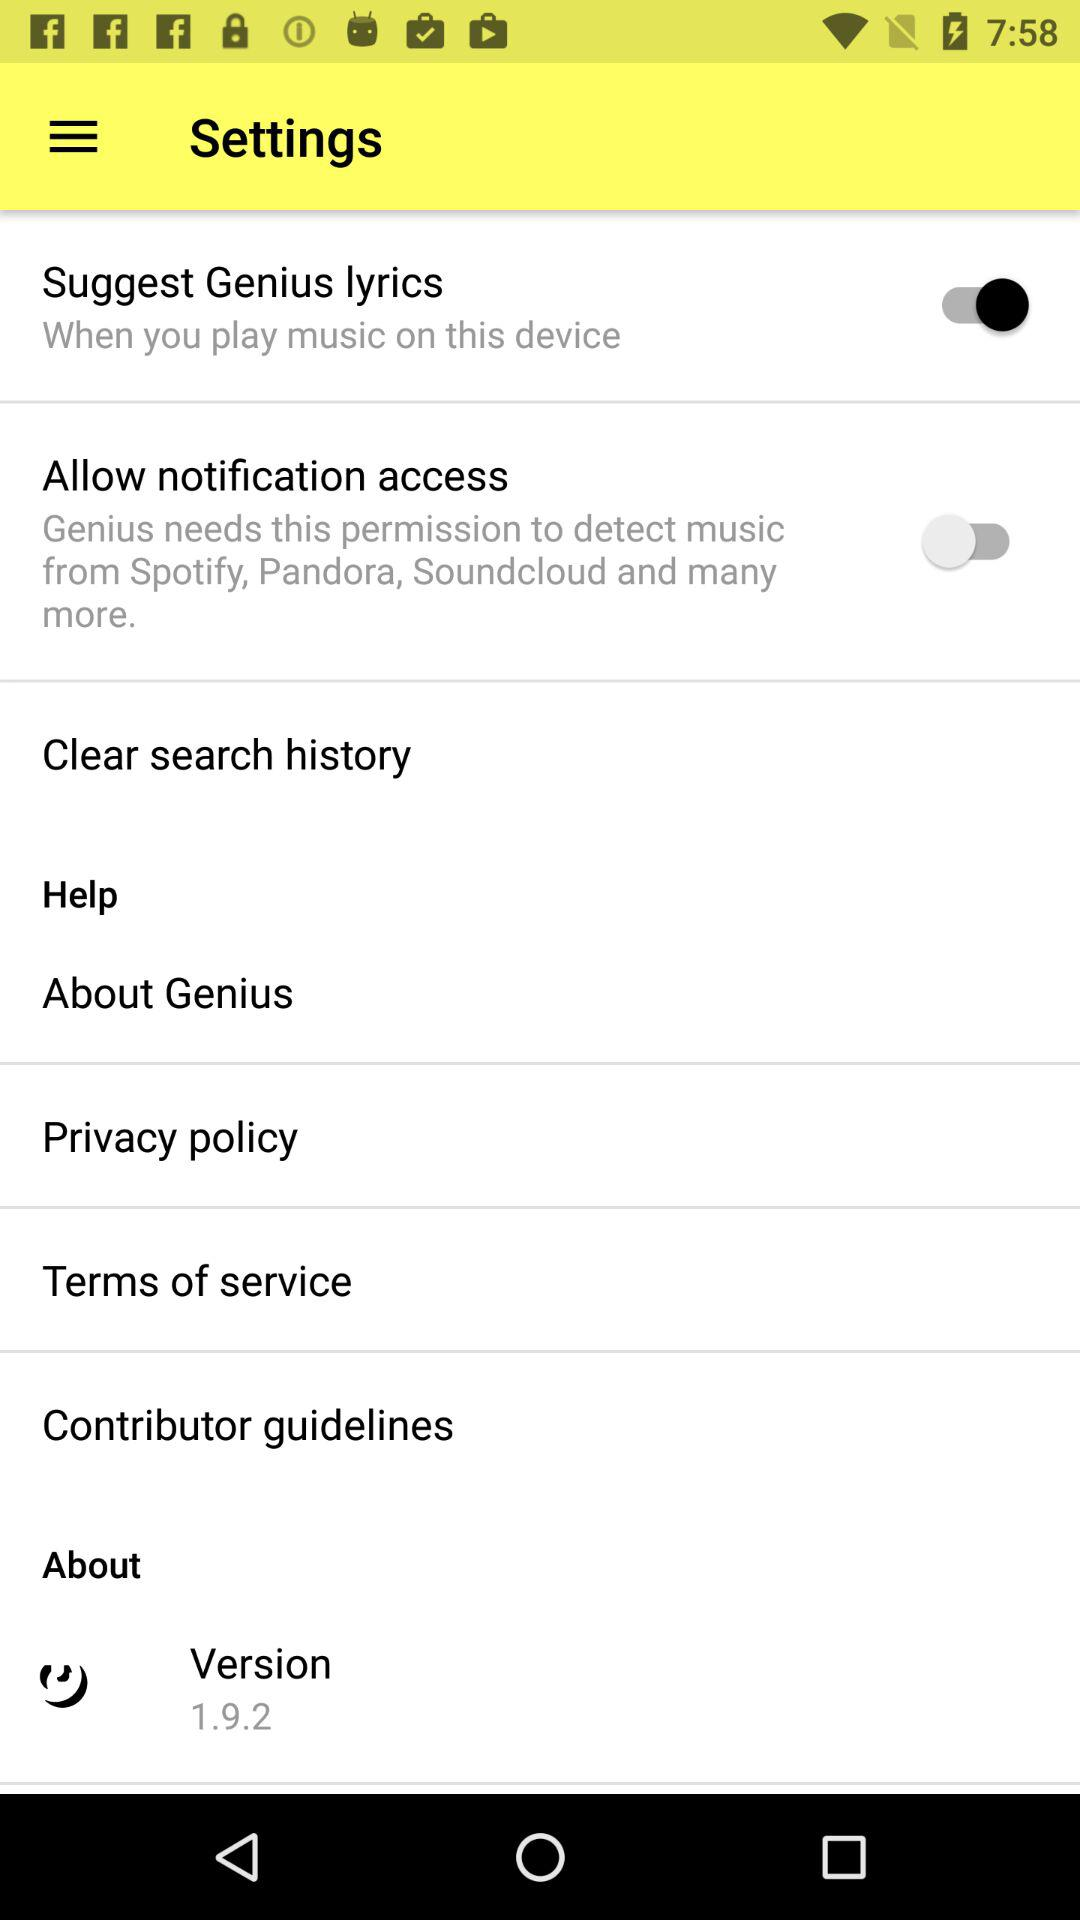What is the status of the allow notification access? The status is "off". 